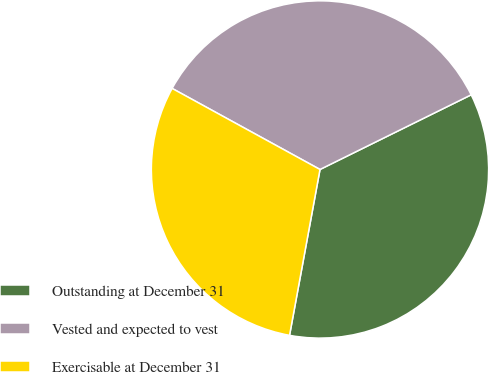<chart> <loc_0><loc_0><loc_500><loc_500><pie_chart><fcel>Outstanding at December 31<fcel>Vested and expected to vest<fcel>Exercisable at December 31<nl><fcel>35.19%<fcel>34.72%<fcel>30.09%<nl></chart> 